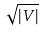<formula> <loc_0><loc_0><loc_500><loc_500>\sqrt { | V | }</formula> 